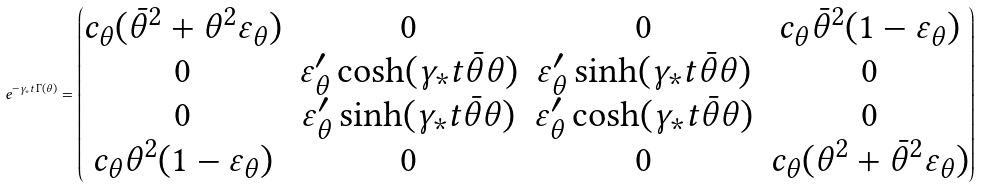<formula> <loc_0><loc_0><loc_500><loc_500>e ^ { - \gamma _ { * } t \, \Gamma ( \theta ) } = \begin{pmatrix} c _ { \theta } ( \bar { \theta } ^ { 2 } + \theta ^ { 2 } \varepsilon _ { \theta } ) & 0 & 0 & c _ { \theta } \bar { \theta } ^ { 2 } ( 1 - \varepsilon _ { \theta } ) \\ 0 & \varepsilon _ { \theta } ^ { \prime } \cosh ( \gamma _ { * } t \bar { \theta } \theta ) & \varepsilon _ { \theta } ^ { \prime } \sinh ( \gamma _ { * } t \bar { \theta } \theta ) & 0 \\ 0 & \varepsilon _ { \theta } ^ { \prime } \sinh ( \gamma _ { * } t \bar { \theta } \theta ) & \varepsilon _ { \theta } ^ { \prime } \cosh ( \gamma _ { * } t \bar { \theta } \theta ) & 0 \\ c _ { \theta } \theta ^ { 2 } ( 1 - \varepsilon _ { \theta } ) & 0 & 0 & c _ { \theta } ( \theta ^ { 2 } + \bar { \theta } ^ { 2 } \varepsilon _ { \theta } ) \end{pmatrix}</formula> 